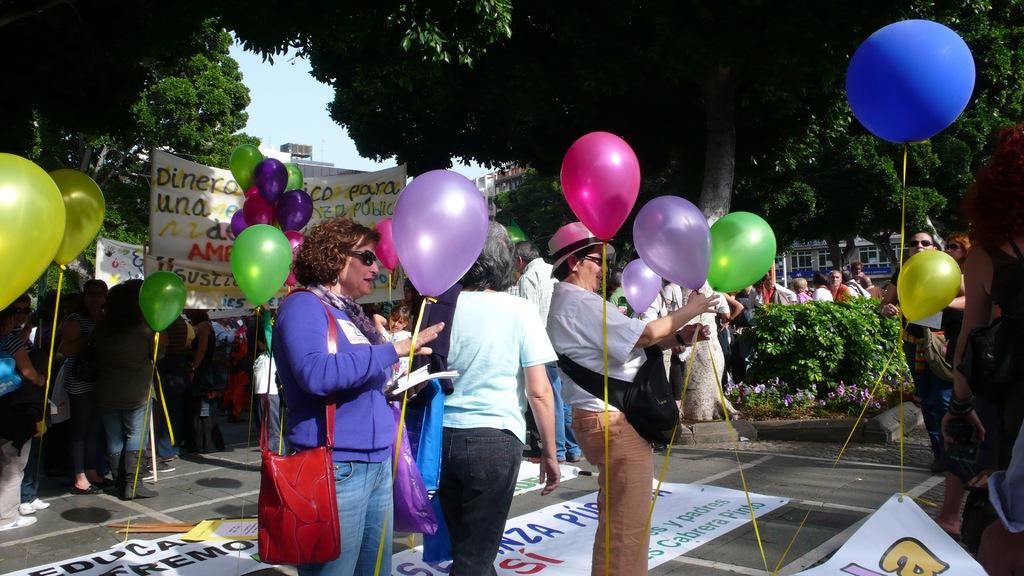What are the people in the image doing? The people in the image are standing in the middle of the image and holding balloons. What else can be seen in the image besides the people? There is a banner at the back side of the image. Are there any natural elements visible in the image? Yes, trees are visible at the top of the image. What type of iron is being used to build the nest in the image? There is no iron or nest present in the image. What is the relation between the people and the banner in the image? The provided facts do not specify any relation between the people and the banner in the image. 